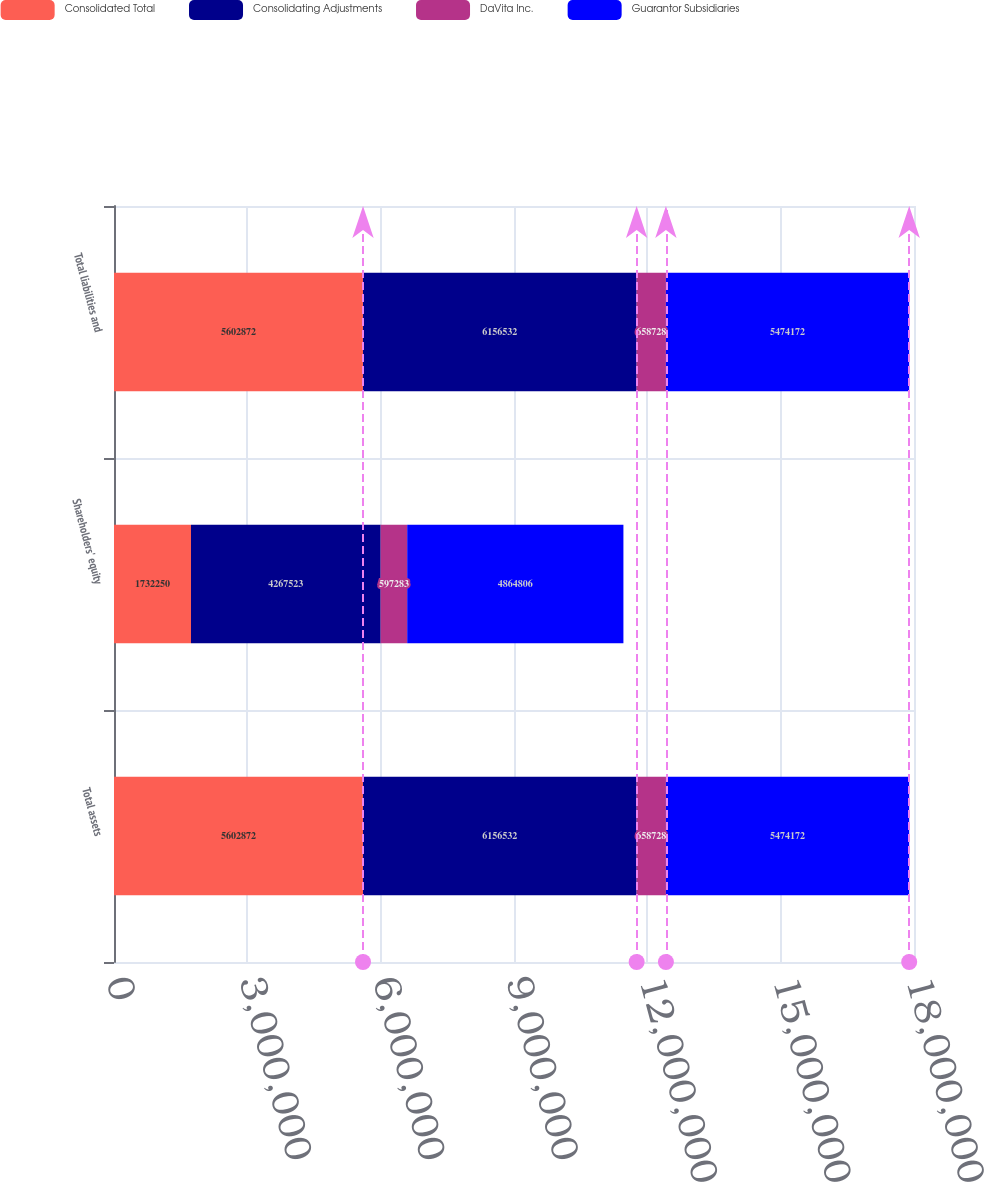Convert chart to OTSL. <chart><loc_0><loc_0><loc_500><loc_500><stacked_bar_chart><ecel><fcel>Total assets<fcel>Shareholders' equity<fcel>Total liabilities and<nl><fcel>Consolidated Total<fcel>5.60287e+06<fcel>1.73225e+06<fcel>5.60287e+06<nl><fcel>Consolidating Adjustments<fcel>6.15653e+06<fcel>4.26752e+06<fcel>6.15653e+06<nl><fcel>DaVita Inc.<fcel>658728<fcel>597283<fcel>658728<nl><fcel>Guarantor Subsidiaries<fcel>5.47417e+06<fcel>4.86481e+06<fcel>5.47417e+06<nl></chart> 